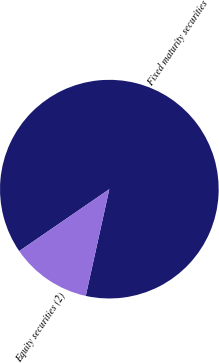Convert chart to OTSL. <chart><loc_0><loc_0><loc_500><loc_500><pie_chart><fcel>Fixed maturity securities<fcel>Equity securities (2)<nl><fcel>88.04%<fcel>11.96%<nl></chart> 